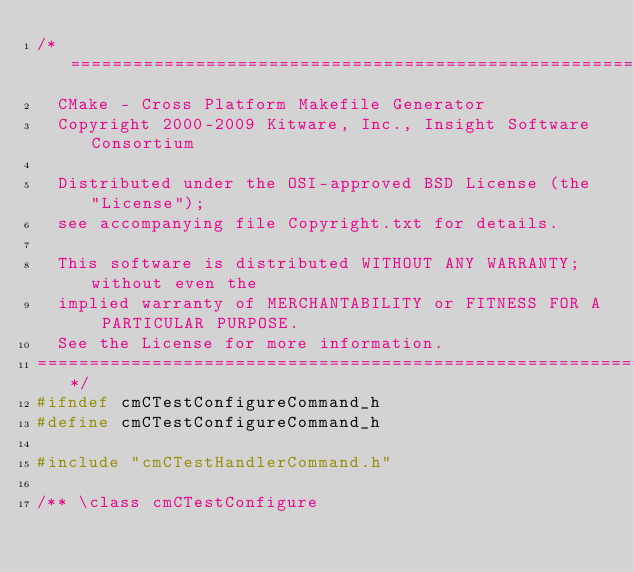Convert code to text. <code><loc_0><loc_0><loc_500><loc_500><_C_>/*============================================================================
  CMake - Cross Platform Makefile Generator
  Copyright 2000-2009 Kitware, Inc., Insight Software Consortium

  Distributed under the OSI-approved BSD License (the "License");
  see accompanying file Copyright.txt for details.

  This software is distributed WITHOUT ANY WARRANTY; without even the
  implied warranty of MERCHANTABILITY or FITNESS FOR A PARTICULAR PURPOSE.
  See the License for more information.
============================================================================*/
#ifndef cmCTestConfigureCommand_h
#define cmCTestConfigureCommand_h

#include "cmCTestHandlerCommand.h"

/** \class cmCTestConfigure</code> 